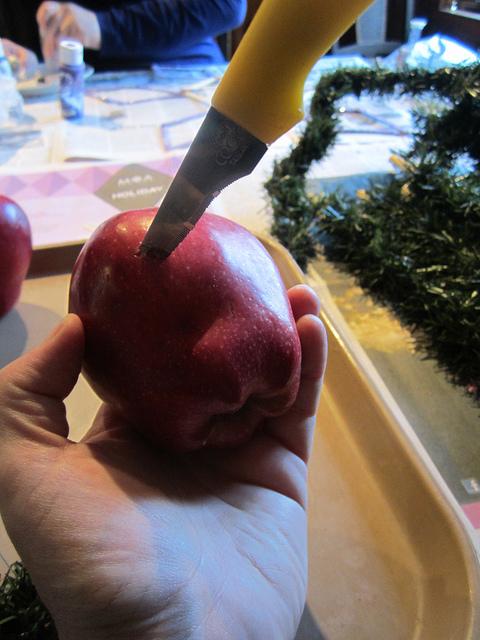What is the knife cutting into?
Short answer required. Apple. What kind of fruit is in the photo?
Be succinct. Apple. What is holding the apple?
Quick response, please. Hand. 